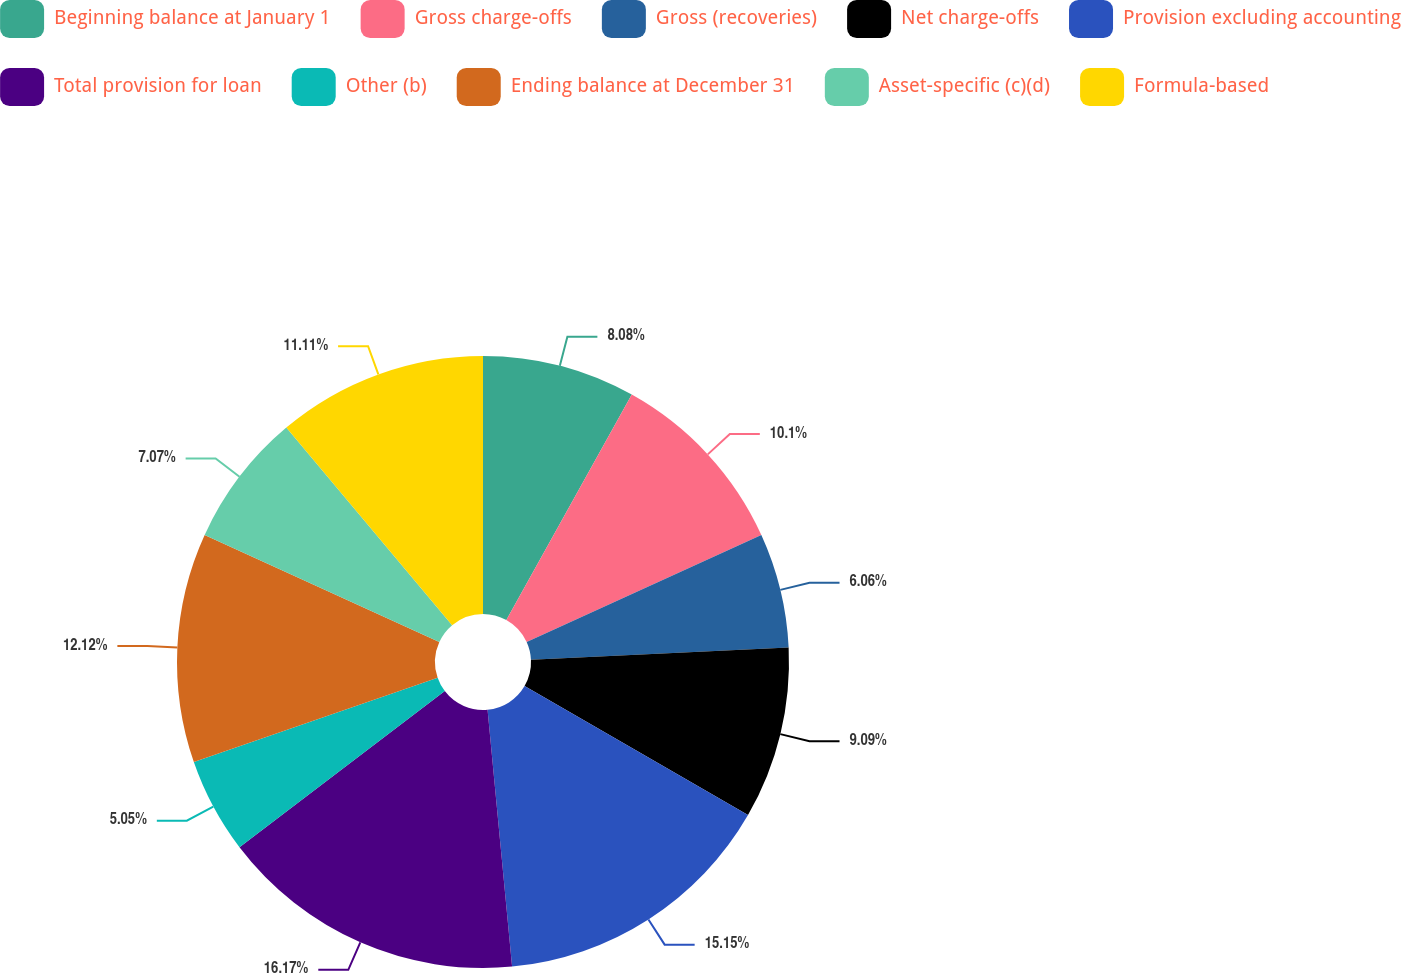<chart> <loc_0><loc_0><loc_500><loc_500><pie_chart><fcel>Beginning balance at January 1<fcel>Gross charge-offs<fcel>Gross (recoveries)<fcel>Net charge-offs<fcel>Provision excluding accounting<fcel>Total provision for loan<fcel>Other (b)<fcel>Ending balance at December 31<fcel>Asset-specific (c)(d)<fcel>Formula-based<nl><fcel>8.08%<fcel>10.1%<fcel>6.06%<fcel>9.09%<fcel>15.15%<fcel>16.16%<fcel>5.05%<fcel>12.12%<fcel>7.07%<fcel>11.11%<nl></chart> 